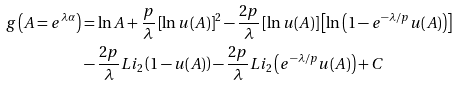<formula> <loc_0><loc_0><loc_500><loc_500>g \left ( A = e ^ { \lambda \alpha } \right ) & = \ln A + \frac { p } { \lambda } \left [ \ln u ( A ) \right ] ^ { 2 } - \frac { 2 p } { \lambda } \left [ \ln u ( A ) \right ] \left [ \ln \left ( 1 - e ^ { - \lambda / p } u ( A ) \right ) \right ] \\ & - \frac { 2 p } { \lambda } L i _ { 2 } \left ( 1 - u ( A ) \right ) - \frac { 2 p } { \lambda } L i _ { 2 } \left ( e ^ { - \lambda / p } u ( A ) \right ) + C</formula> 